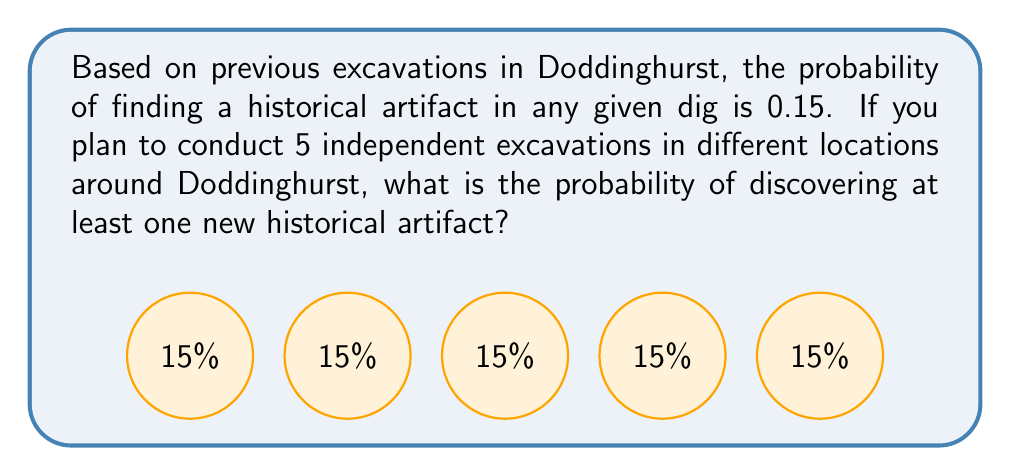Show me your answer to this math problem. Let's approach this step-by-step using Bayesian probability:

1) First, let's define our events:
   $A$ = finding at least one artifact in 5 excavations
   $\bar{A}$ = finding no artifacts in 5 excavations

2) We're looking for $P(A)$, but it's easier to calculate $P(\bar{A})$ and then use the complement rule.

3) The probability of not finding an artifact in a single excavation is:
   $P(\text{no artifact}) = 1 - 0.15 = 0.85$

4) For 5 independent excavations, the probability of finding no artifacts is:
   $P(\bar{A}) = 0.85^5$

5) Using the complement rule:
   $P(A) = 1 - P(\bar{A}) = 1 - 0.85^5$

6) Let's calculate this:
   $P(A) = 1 - 0.85^5 = 1 - 0.4437 = 0.5563$

7) Converting to a percentage:
   $0.5563 \times 100\% = 55.63\%$

Thus, the probability of discovering at least one new historical artifact in 5 excavations is approximately 55.63%.
Answer: $55.63\%$ 